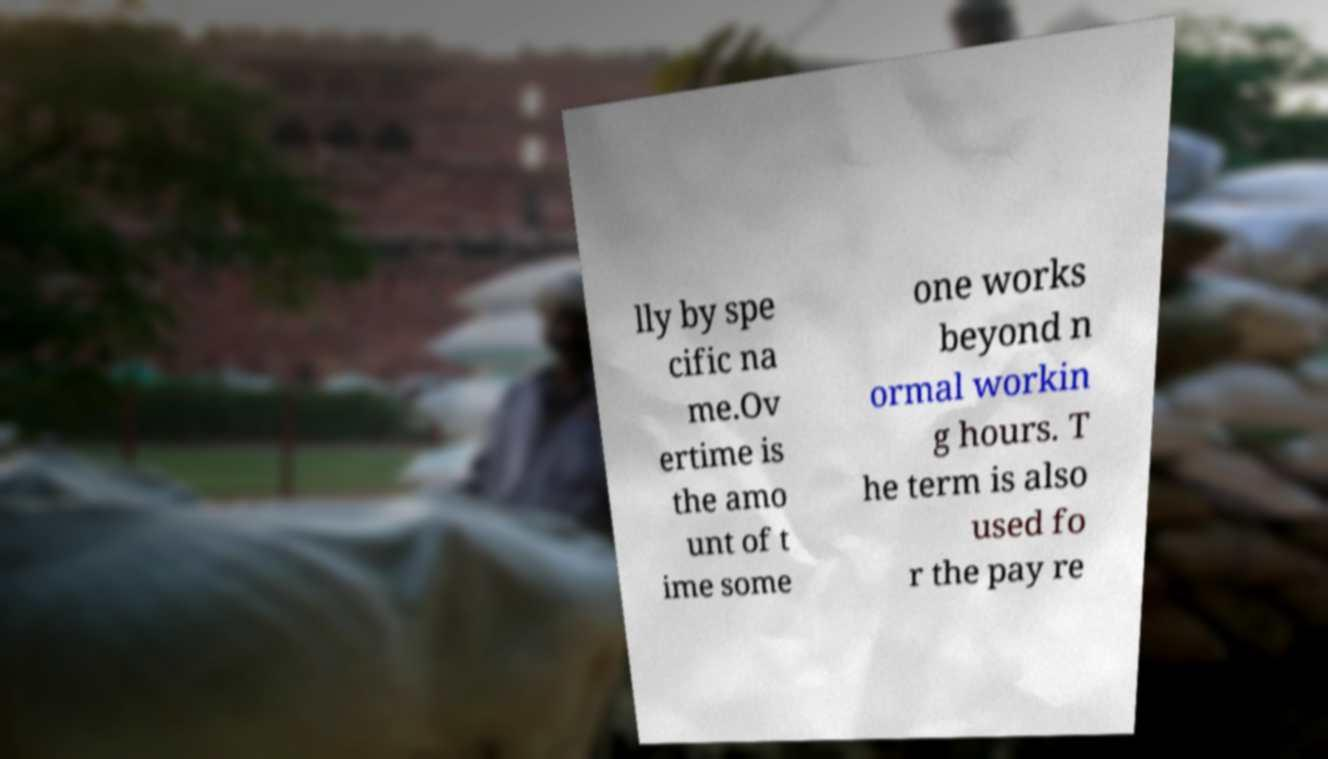There's text embedded in this image that I need extracted. Can you transcribe it verbatim? lly by spe cific na me.Ov ertime is the amo unt of t ime some one works beyond n ormal workin g hours. T he term is also used fo r the pay re 